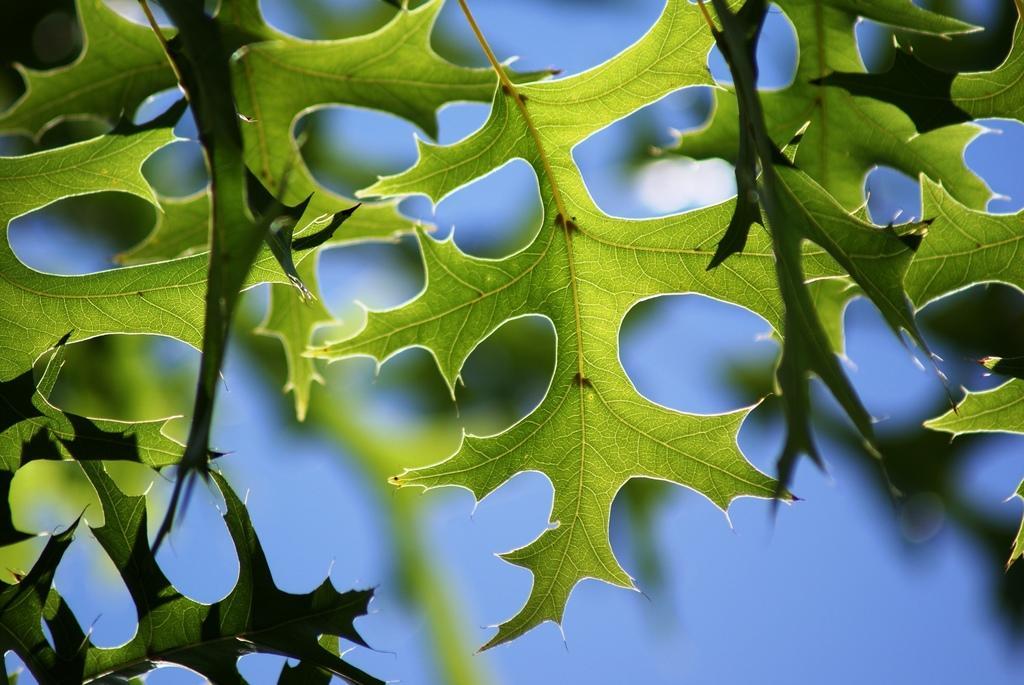Please provide a concise description of this image. In this picture I can see leaves of a tree. 